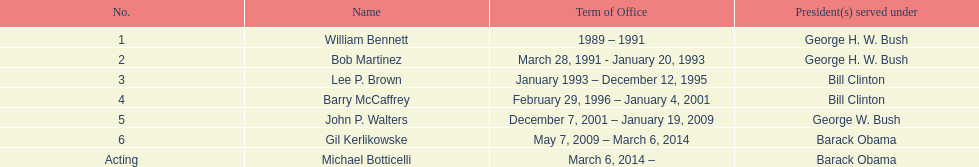What were the total number of years bob martinez served in office? 2. 